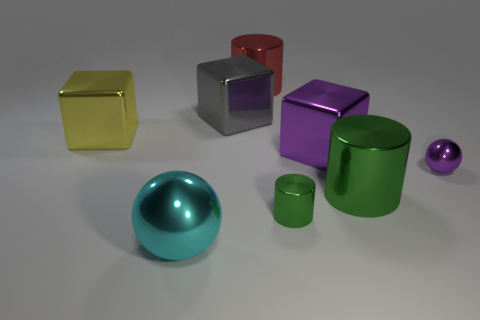Add 2 big blue metallic things. How many objects exist? 10 Subtract all balls. How many objects are left? 6 Subtract all tiny blue rubber balls. Subtract all big cubes. How many objects are left? 5 Add 1 gray cubes. How many gray cubes are left? 2 Add 4 large brown cylinders. How many large brown cylinders exist? 4 Subtract 0 brown cylinders. How many objects are left? 8 